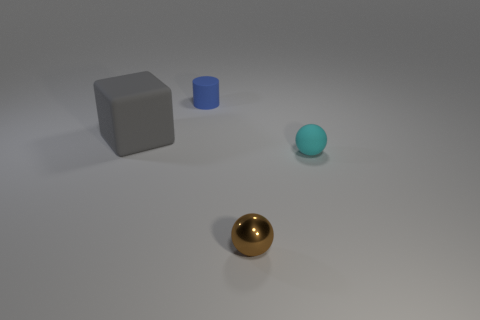What color is the tiny rubber object that is behind the matte object that is right of the small cylinder?
Make the answer very short. Blue. What number of small cyan spheres have the same material as the tiny blue thing?
Offer a very short reply. 1. What number of matte objects are small brown balls or tiny gray objects?
Your response must be concise. 0. There is a cyan thing that is the same size as the blue matte cylinder; what is it made of?
Your answer should be compact. Rubber. Are there any brown things made of the same material as the cyan object?
Provide a short and direct response. No. There is a small rubber object that is in front of the small matte object that is behind the rubber object that is left of the small blue object; what is its shape?
Give a very brief answer. Sphere. Do the blue matte cylinder and the sphere left of the rubber sphere have the same size?
Ensure brevity in your answer.  Yes. There is a thing that is both in front of the tiny blue thing and to the left of the tiny brown metal ball; what is its shape?
Offer a terse response. Cube. What number of large things are gray matte objects or red rubber things?
Your answer should be very brief. 1. Are there the same number of tiny cylinders that are left of the gray object and blue objects that are to the right of the tiny matte sphere?
Your answer should be compact. Yes. 